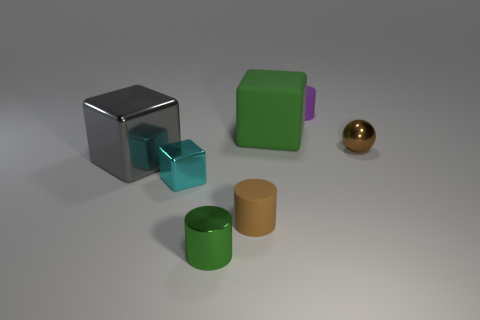Add 1 big brown metal things. How many objects exist? 8 Subtract all cylinders. How many objects are left? 4 Subtract all small metal objects. Subtract all small green things. How many objects are left? 3 Add 1 metallic balls. How many metallic balls are left? 2 Add 7 purple rubber things. How many purple rubber things exist? 8 Subtract 0 cyan cylinders. How many objects are left? 7 